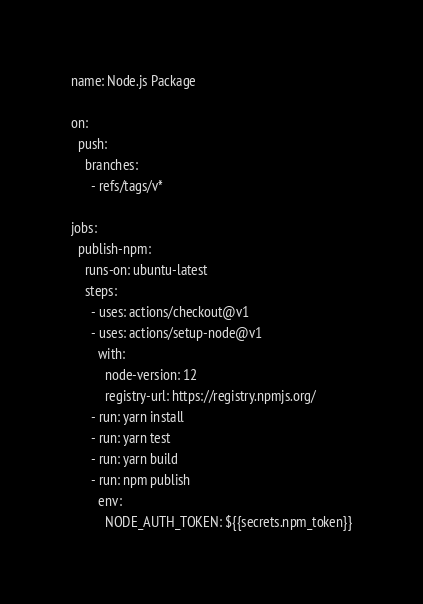Convert code to text. <code><loc_0><loc_0><loc_500><loc_500><_YAML_>name: Node.js Package

on:
  push: 
    branches: 
      - refs/tags/v*

jobs:
  publish-npm:
    runs-on: ubuntu-latest
    steps:
      - uses: actions/checkout@v1
      - uses: actions/setup-node@v1
        with:
          node-version: 12
          registry-url: https://registry.npmjs.org/
      - run: yarn install
      - run: yarn test
      - run: yarn build
      - run: npm publish
        env:
          NODE_AUTH_TOKEN: ${{secrets.npm_token}}
</code> 